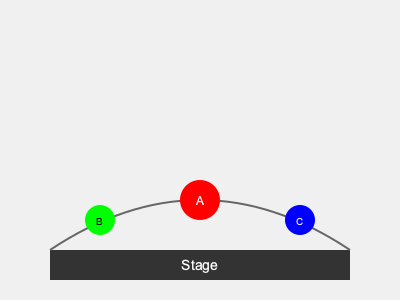Based on the concert venue seating chart, which area would be most effective for initiating a call-and-response interaction with the audience to maximize energy and participation? To determine the most effective area for initiating a call-and-response interaction, we need to consider several factors:

1. Visibility: The chosen area should be easily visible to most of the audience.
2. Centrality: A central location helps engage the entire crowd more effectively.
3. Proximity to the stage: Being closer to the stage allows for better communication between the band and the audience.
4. Size of the area: A larger area can accommodate more people, potentially increasing participation.

Let's analyze each area:

A. This is the largest and most central area, located closest to the stage. It offers the best visibility and allows for maximum crowd participation.

B. This area is smaller and off to the side. While it's close to the stage, it may not be as visible to the entire audience.

C. Similar to B, this area is smaller and off to the side. It has the same limitations as B in terms of visibility and crowd engagement.

Given these factors, area A is the most effective for initiating a call-and-response interaction. Its central location, proximity to the stage, and larger size make it ideal for maximizing energy and participation across the entire venue.
Answer: Area A 